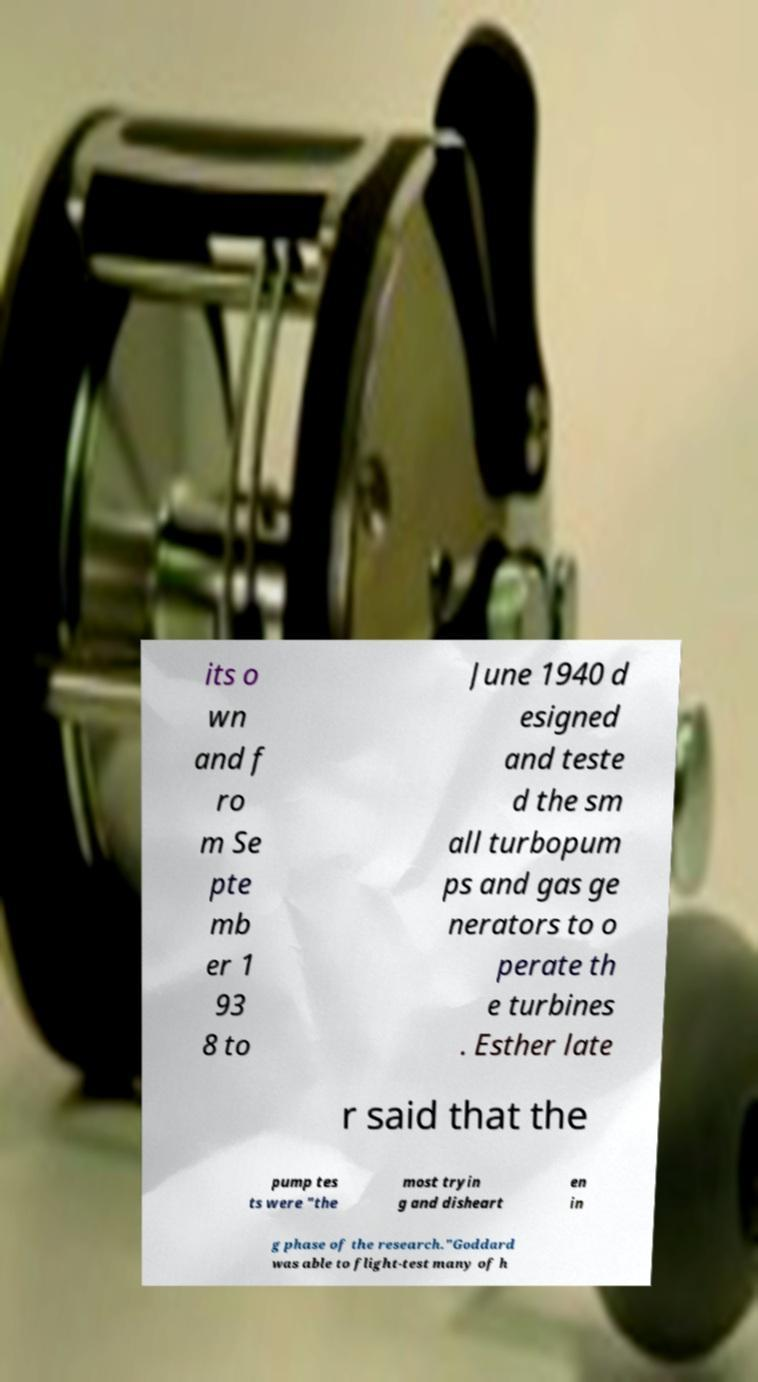For documentation purposes, I need the text within this image transcribed. Could you provide that? its o wn and f ro m Se pte mb er 1 93 8 to June 1940 d esigned and teste d the sm all turbopum ps and gas ge nerators to o perate th e turbines . Esther late r said that the pump tes ts were "the most tryin g and disheart en in g phase of the research."Goddard was able to flight-test many of h 